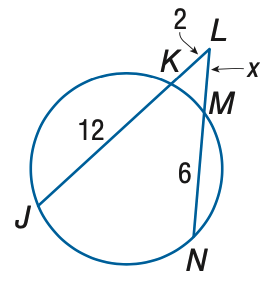Answer the mathemtical geometry problem and directly provide the correct option letter.
Question: Find x to the nearest tenth.
Choices: A: 2.1 B: 2.6 C: 3.1 D: 3.6 C 